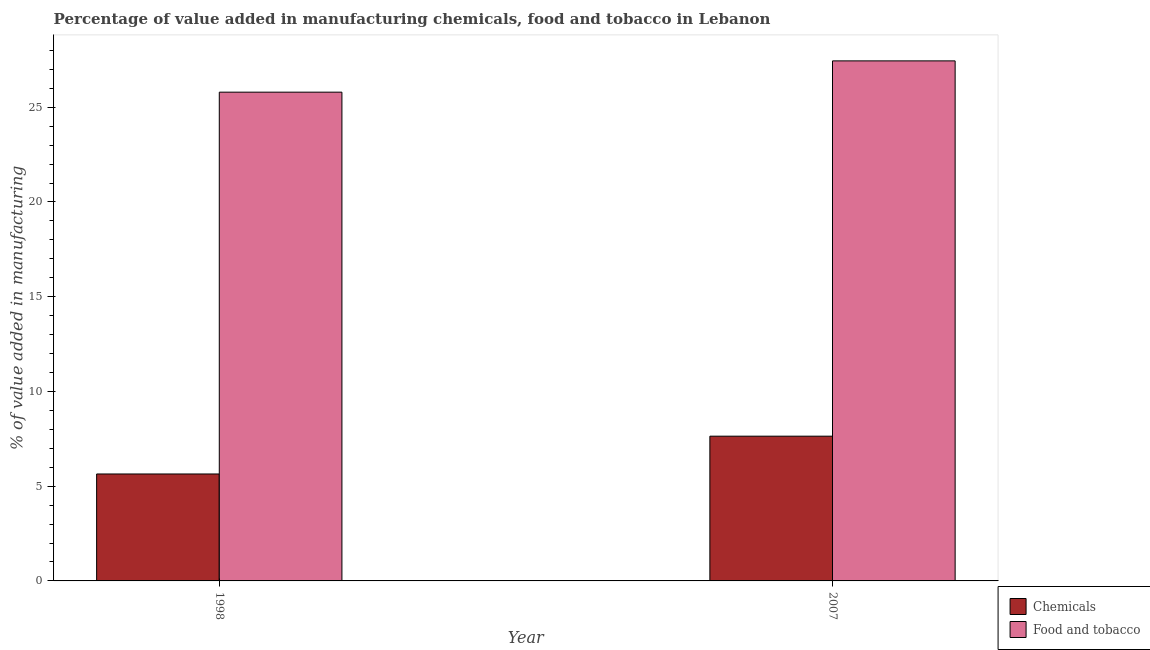How many different coloured bars are there?
Keep it short and to the point. 2. How many groups of bars are there?
Provide a short and direct response. 2. How many bars are there on the 1st tick from the right?
Provide a short and direct response. 2. What is the label of the 1st group of bars from the left?
Give a very brief answer. 1998. In how many cases, is the number of bars for a given year not equal to the number of legend labels?
Offer a very short reply. 0. What is the value added by  manufacturing chemicals in 1998?
Ensure brevity in your answer.  5.64. Across all years, what is the maximum value added by  manufacturing chemicals?
Your answer should be very brief. 7.64. Across all years, what is the minimum value added by  manufacturing chemicals?
Your answer should be compact. 5.64. What is the total value added by manufacturing food and tobacco in the graph?
Make the answer very short. 53.24. What is the difference between the value added by manufacturing food and tobacco in 1998 and that in 2007?
Give a very brief answer. -1.65. What is the difference between the value added by  manufacturing chemicals in 1998 and the value added by manufacturing food and tobacco in 2007?
Your answer should be compact. -1.99. What is the average value added by  manufacturing chemicals per year?
Your answer should be compact. 6.64. In the year 2007, what is the difference between the value added by  manufacturing chemicals and value added by manufacturing food and tobacco?
Offer a terse response. 0. In how many years, is the value added by  manufacturing chemicals greater than 1 %?
Provide a short and direct response. 2. What is the ratio of the value added by manufacturing food and tobacco in 1998 to that in 2007?
Ensure brevity in your answer.  0.94. Is the value added by  manufacturing chemicals in 1998 less than that in 2007?
Give a very brief answer. Yes. What does the 1st bar from the left in 1998 represents?
Offer a terse response. Chemicals. What does the 1st bar from the right in 2007 represents?
Your answer should be very brief. Food and tobacco. How many bars are there?
Provide a short and direct response. 4. Are all the bars in the graph horizontal?
Offer a terse response. No. Does the graph contain any zero values?
Give a very brief answer. No. Does the graph contain grids?
Offer a very short reply. No. Where does the legend appear in the graph?
Ensure brevity in your answer.  Bottom right. How are the legend labels stacked?
Provide a succinct answer. Vertical. What is the title of the graph?
Provide a short and direct response. Percentage of value added in manufacturing chemicals, food and tobacco in Lebanon. What is the label or title of the Y-axis?
Give a very brief answer. % of value added in manufacturing. What is the % of value added in manufacturing in Chemicals in 1998?
Ensure brevity in your answer.  5.64. What is the % of value added in manufacturing in Food and tobacco in 1998?
Offer a very short reply. 25.79. What is the % of value added in manufacturing of Chemicals in 2007?
Make the answer very short. 7.64. What is the % of value added in manufacturing of Food and tobacco in 2007?
Ensure brevity in your answer.  27.45. Across all years, what is the maximum % of value added in manufacturing in Chemicals?
Make the answer very short. 7.64. Across all years, what is the maximum % of value added in manufacturing in Food and tobacco?
Offer a very short reply. 27.45. Across all years, what is the minimum % of value added in manufacturing of Chemicals?
Your answer should be compact. 5.64. Across all years, what is the minimum % of value added in manufacturing in Food and tobacco?
Make the answer very short. 25.79. What is the total % of value added in manufacturing in Chemicals in the graph?
Your answer should be very brief. 13.28. What is the total % of value added in manufacturing of Food and tobacco in the graph?
Your answer should be compact. 53.24. What is the difference between the % of value added in manufacturing of Chemicals in 1998 and that in 2007?
Keep it short and to the point. -1.99. What is the difference between the % of value added in manufacturing in Food and tobacco in 1998 and that in 2007?
Make the answer very short. -1.65. What is the difference between the % of value added in manufacturing of Chemicals in 1998 and the % of value added in manufacturing of Food and tobacco in 2007?
Offer a terse response. -21.8. What is the average % of value added in manufacturing of Chemicals per year?
Make the answer very short. 6.64. What is the average % of value added in manufacturing in Food and tobacco per year?
Offer a terse response. 26.62. In the year 1998, what is the difference between the % of value added in manufacturing in Chemicals and % of value added in manufacturing in Food and tobacco?
Ensure brevity in your answer.  -20.15. In the year 2007, what is the difference between the % of value added in manufacturing of Chemicals and % of value added in manufacturing of Food and tobacco?
Make the answer very short. -19.81. What is the ratio of the % of value added in manufacturing of Chemicals in 1998 to that in 2007?
Provide a short and direct response. 0.74. What is the ratio of the % of value added in manufacturing in Food and tobacco in 1998 to that in 2007?
Provide a short and direct response. 0.94. What is the difference between the highest and the second highest % of value added in manufacturing of Chemicals?
Your answer should be very brief. 1.99. What is the difference between the highest and the second highest % of value added in manufacturing of Food and tobacco?
Your answer should be compact. 1.65. What is the difference between the highest and the lowest % of value added in manufacturing in Chemicals?
Provide a short and direct response. 1.99. What is the difference between the highest and the lowest % of value added in manufacturing in Food and tobacco?
Your answer should be very brief. 1.65. 